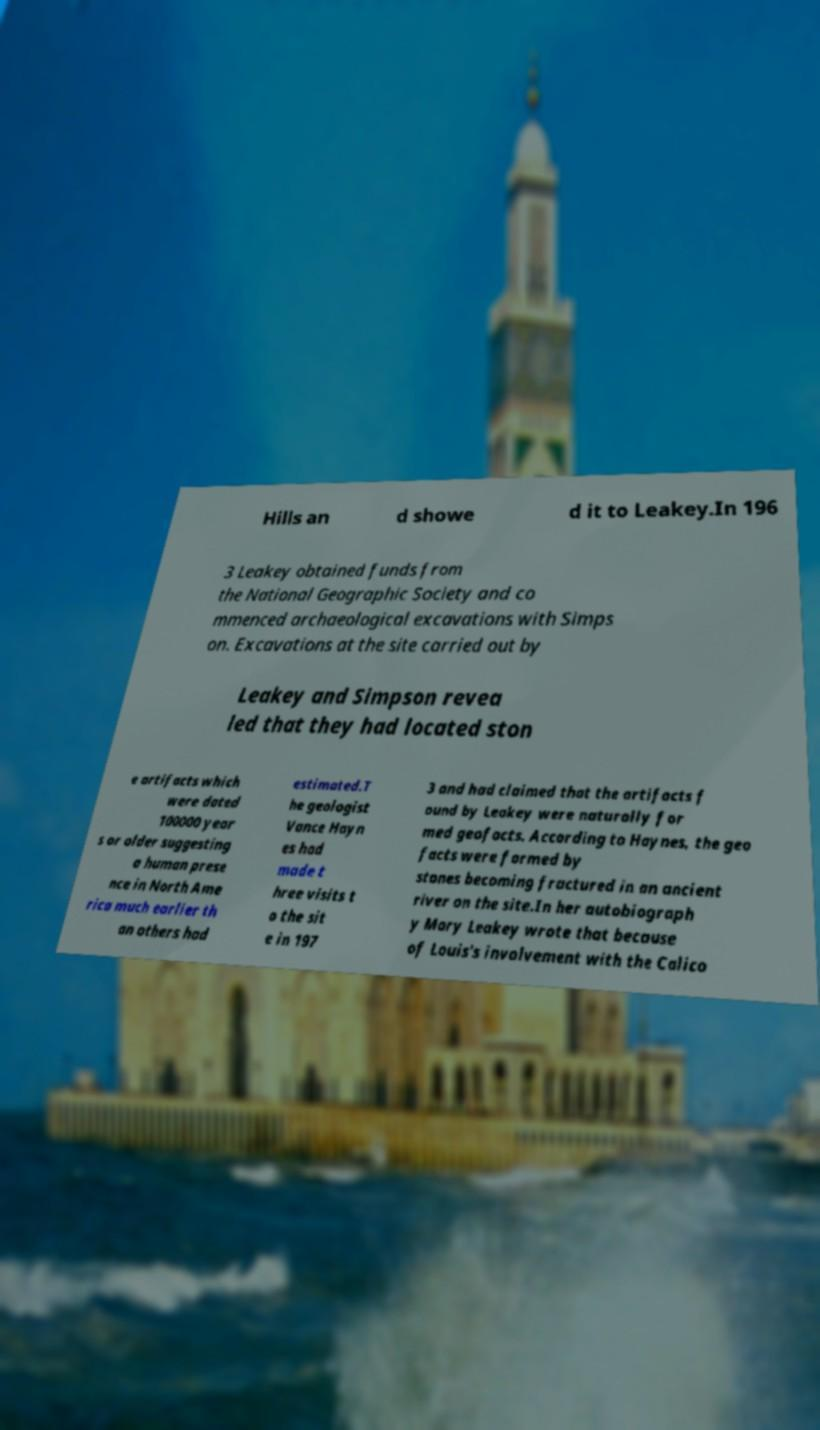Could you extract and type out the text from this image? Hills an d showe d it to Leakey.In 196 3 Leakey obtained funds from the National Geographic Society and co mmenced archaeological excavations with Simps on. Excavations at the site carried out by Leakey and Simpson revea led that they had located ston e artifacts which were dated 100000 year s or older suggesting a human prese nce in North Ame rica much earlier th an others had estimated.T he geologist Vance Hayn es had made t hree visits t o the sit e in 197 3 and had claimed that the artifacts f ound by Leakey were naturally for med geofacts. According to Haynes, the geo facts were formed by stones becoming fractured in an ancient river on the site.In her autobiograph y Mary Leakey wrote that because of Louis's involvement with the Calico 